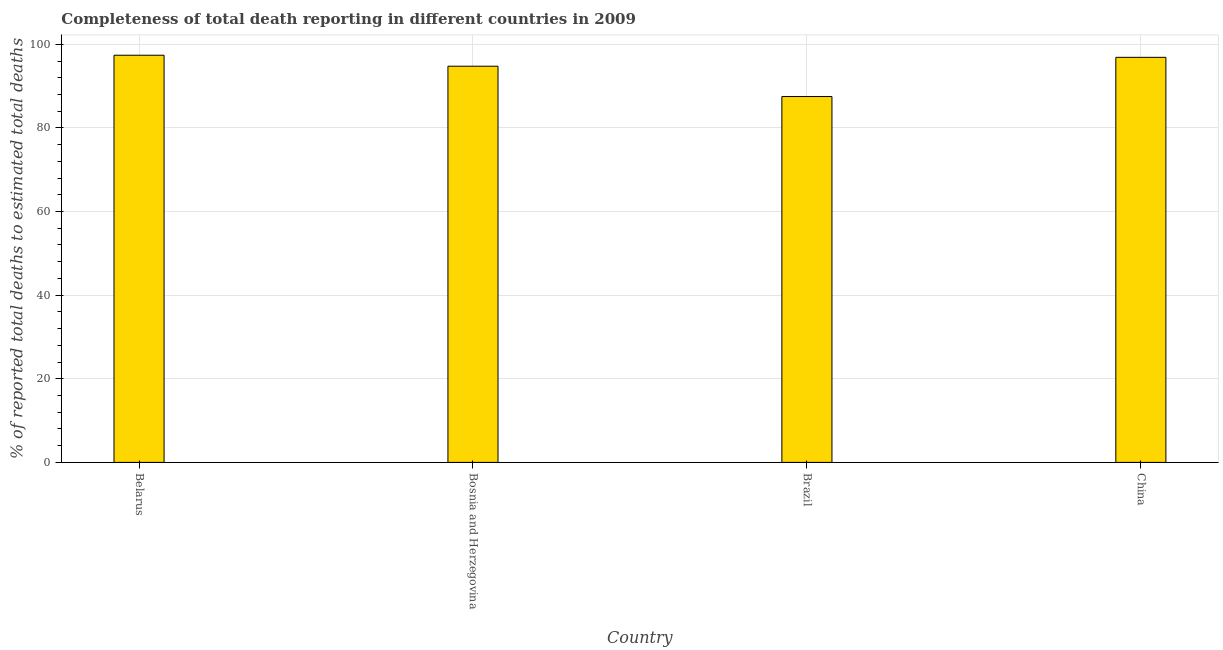Does the graph contain any zero values?
Offer a very short reply. No. What is the title of the graph?
Offer a terse response. Completeness of total death reporting in different countries in 2009. What is the label or title of the X-axis?
Keep it short and to the point. Country. What is the label or title of the Y-axis?
Offer a very short reply. % of reported total deaths to estimated total deaths. What is the completeness of total death reports in Brazil?
Offer a very short reply. 87.51. Across all countries, what is the maximum completeness of total death reports?
Give a very brief answer. 97.39. Across all countries, what is the minimum completeness of total death reports?
Offer a terse response. 87.51. In which country was the completeness of total death reports maximum?
Provide a succinct answer. Belarus. What is the sum of the completeness of total death reports?
Offer a terse response. 376.54. What is the difference between the completeness of total death reports in Brazil and China?
Offer a very short reply. -9.38. What is the average completeness of total death reports per country?
Make the answer very short. 94.14. What is the median completeness of total death reports?
Your answer should be compact. 95.82. What is the ratio of the completeness of total death reports in Belarus to that in Brazil?
Give a very brief answer. 1.11. What is the difference between the highest and the second highest completeness of total death reports?
Ensure brevity in your answer.  0.5. What is the difference between the highest and the lowest completeness of total death reports?
Give a very brief answer. 9.88. In how many countries, is the completeness of total death reports greater than the average completeness of total death reports taken over all countries?
Your response must be concise. 3. How many bars are there?
Your answer should be very brief. 4. How many countries are there in the graph?
Your answer should be compact. 4. What is the difference between two consecutive major ticks on the Y-axis?
Your response must be concise. 20. Are the values on the major ticks of Y-axis written in scientific E-notation?
Offer a terse response. No. What is the % of reported total deaths to estimated total deaths of Belarus?
Provide a succinct answer. 97.39. What is the % of reported total deaths to estimated total deaths in Bosnia and Herzegovina?
Your response must be concise. 94.76. What is the % of reported total deaths to estimated total deaths in Brazil?
Give a very brief answer. 87.51. What is the % of reported total deaths to estimated total deaths in China?
Give a very brief answer. 96.89. What is the difference between the % of reported total deaths to estimated total deaths in Belarus and Bosnia and Herzegovina?
Offer a terse response. 2.63. What is the difference between the % of reported total deaths to estimated total deaths in Belarus and Brazil?
Give a very brief answer. 9.88. What is the difference between the % of reported total deaths to estimated total deaths in Belarus and China?
Ensure brevity in your answer.  0.5. What is the difference between the % of reported total deaths to estimated total deaths in Bosnia and Herzegovina and Brazil?
Your answer should be compact. 7.25. What is the difference between the % of reported total deaths to estimated total deaths in Bosnia and Herzegovina and China?
Make the answer very short. -2.12. What is the difference between the % of reported total deaths to estimated total deaths in Brazil and China?
Make the answer very short. -9.38. What is the ratio of the % of reported total deaths to estimated total deaths in Belarus to that in Bosnia and Herzegovina?
Provide a succinct answer. 1.03. What is the ratio of the % of reported total deaths to estimated total deaths in Belarus to that in Brazil?
Your answer should be very brief. 1.11. What is the ratio of the % of reported total deaths to estimated total deaths in Bosnia and Herzegovina to that in Brazil?
Offer a terse response. 1.08. What is the ratio of the % of reported total deaths to estimated total deaths in Bosnia and Herzegovina to that in China?
Offer a terse response. 0.98. What is the ratio of the % of reported total deaths to estimated total deaths in Brazil to that in China?
Keep it short and to the point. 0.9. 